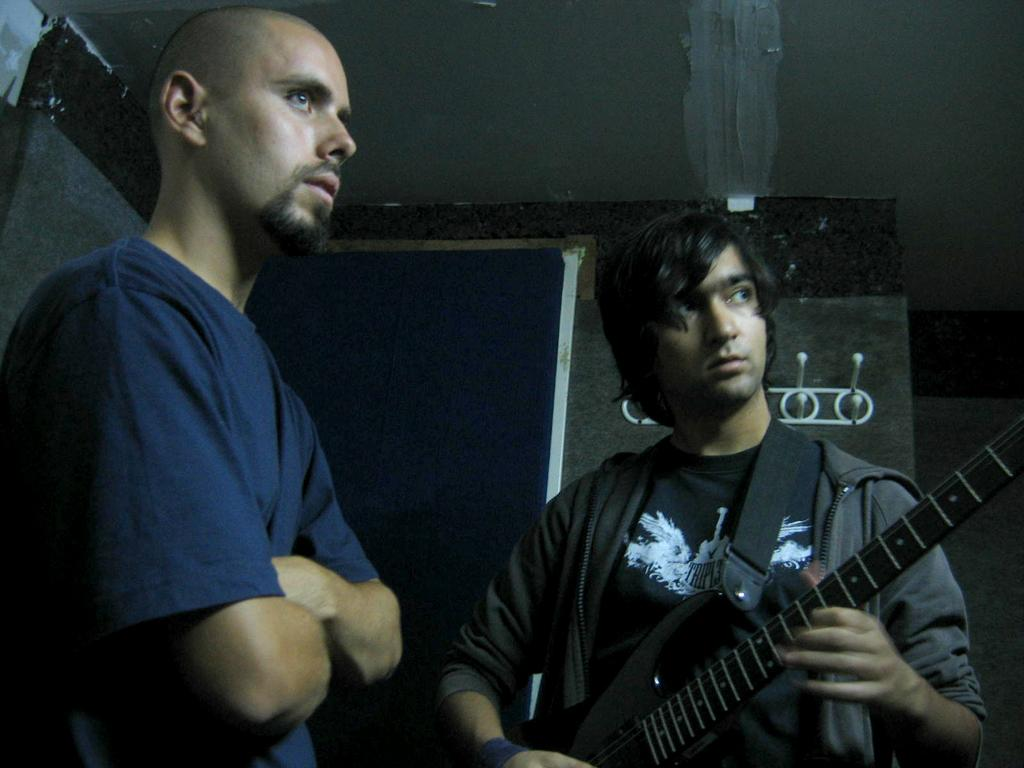How many people are in the image? There are two persons standing in the image. What is the person on the right holding? The person on the right is holding a guitar. What can be seen in the background of the image? There is a wall, a door, and a hanger in the background of the image. What advice is the person on the left giving to the person on the right in the image? There is no indication in the image that the person on the left is giving advice to the person on the right. What type of trade is being conducted between the two persons in the image? There is no indication in the image that a trade is being conducted between the two persons. 